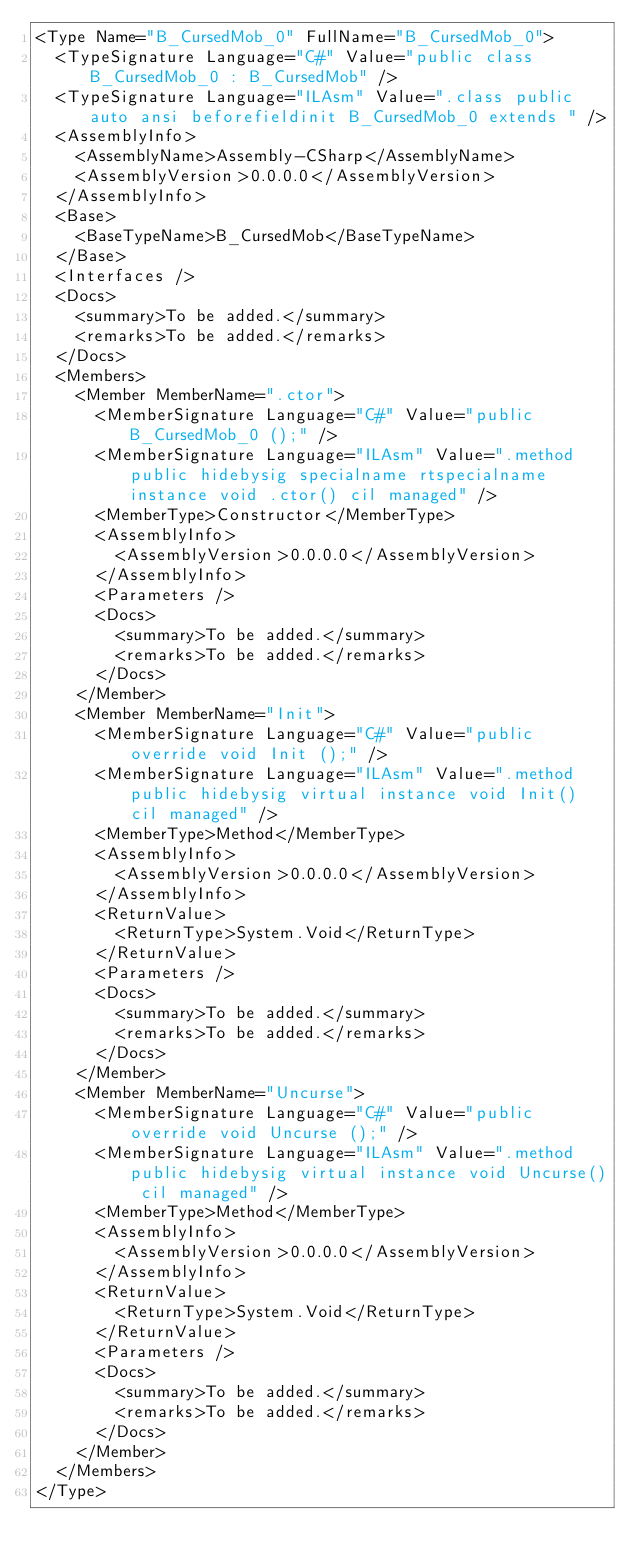Convert code to text. <code><loc_0><loc_0><loc_500><loc_500><_XML_><Type Name="B_CursedMob_0" FullName="B_CursedMob_0">
  <TypeSignature Language="C#" Value="public class B_CursedMob_0 : B_CursedMob" />
  <TypeSignature Language="ILAsm" Value=".class public auto ansi beforefieldinit B_CursedMob_0 extends " />
  <AssemblyInfo>
    <AssemblyName>Assembly-CSharp</AssemblyName>
    <AssemblyVersion>0.0.0.0</AssemblyVersion>
  </AssemblyInfo>
  <Base>
    <BaseTypeName>B_CursedMob</BaseTypeName>
  </Base>
  <Interfaces />
  <Docs>
    <summary>To be added.</summary>
    <remarks>To be added.</remarks>
  </Docs>
  <Members>
    <Member MemberName=".ctor">
      <MemberSignature Language="C#" Value="public B_CursedMob_0 ();" />
      <MemberSignature Language="ILAsm" Value=".method public hidebysig specialname rtspecialname instance void .ctor() cil managed" />
      <MemberType>Constructor</MemberType>
      <AssemblyInfo>
        <AssemblyVersion>0.0.0.0</AssemblyVersion>
      </AssemblyInfo>
      <Parameters />
      <Docs>
        <summary>To be added.</summary>
        <remarks>To be added.</remarks>
      </Docs>
    </Member>
    <Member MemberName="Init">
      <MemberSignature Language="C#" Value="public override void Init ();" />
      <MemberSignature Language="ILAsm" Value=".method public hidebysig virtual instance void Init() cil managed" />
      <MemberType>Method</MemberType>
      <AssemblyInfo>
        <AssemblyVersion>0.0.0.0</AssemblyVersion>
      </AssemblyInfo>
      <ReturnValue>
        <ReturnType>System.Void</ReturnType>
      </ReturnValue>
      <Parameters />
      <Docs>
        <summary>To be added.</summary>
        <remarks>To be added.</remarks>
      </Docs>
    </Member>
    <Member MemberName="Uncurse">
      <MemberSignature Language="C#" Value="public override void Uncurse ();" />
      <MemberSignature Language="ILAsm" Value=".method public hidebysig virtual instance void Uncurse() cil managed" />
      <MemberType>Method</MemberType>
      <AssemblyInfo>
        <AssemblyVersion>0.0.0.0</AssemblyVersion>
      </AssemblyInfo>
      <ReturnValue>
        <ReturnType>System.Void</ReturnType>
      </ReturnValue>
      <Parameters />
      <Docs>
        <summary>To be added.</summary>
        <remarks>To be added.</remarks>
      </Docs>
    </Member>
  </Members>
</Type>
</code> 